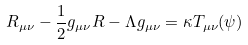Convert formula to latex. <formula><loc_0><loc_0><loc_500><loc_500>R _ { \mu \nu } - \frac { 1 } { 2 } g _ { \mu \nu } R - \Lambda g _ { \mu \nu } = \kappa T _ { \mu \nu } ( \psi )</formula> 